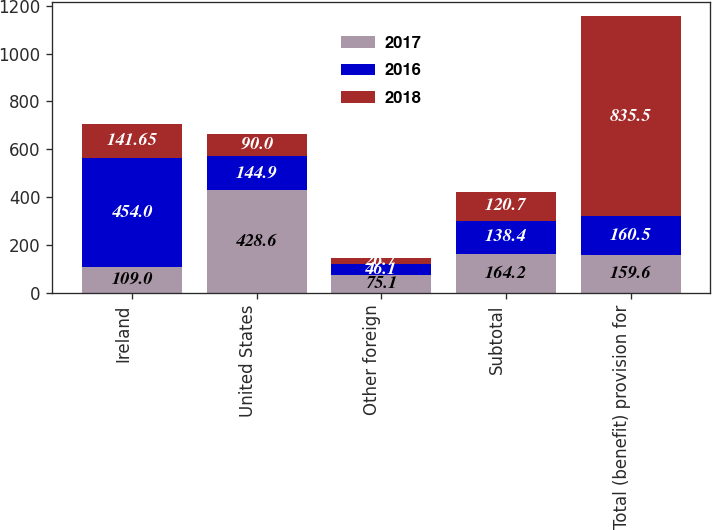<chart> <loc_0><loc_0><loc_500><loc_500><stacked_bar_chart><ecel><fcel>Ireland<fcel>United States<fcel>Other foreign<fcel>Subtotal<fcel>Total (benefit) provision for<nl><fcel>2017<fcel>109<fcel>428.6<fcel>75.1<fcel>164.2<fcel>159.6<nl><fcel>2016<fcel>454<fcel>144.9<fcel>46.1<fcel>138.4<fcel>160.5<nl><fcel>2018<fcel>141.65<fcel>90<fcel>26.7<fcel>120.7<fcel>835.5<nl></chart> 